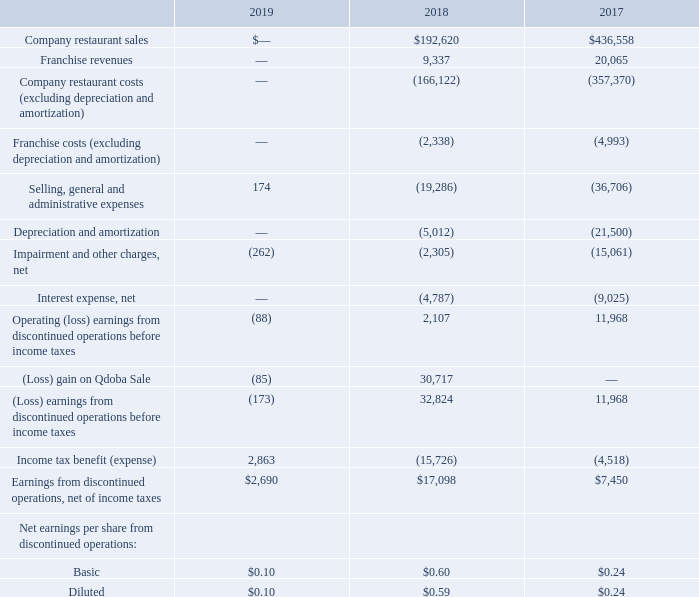The following table summarizes the Qdoba results for each period (in thousands, except per share data):
Selling, general and administrative expenses presented in the table above include corporate costs directly in support of Qdoba operations. All other corporate costs were classified in results of continuing operations. Our credit facility required us to make a mandatory prepayment (“Qdoba Prepayment”) on our term loan upon the closing of the Qdoba Sale, which was $260.0 million. Interest expense associated with our credit facility was allocated to discontinued operations based on our estimate of the mandatory prepayment that was made upon closing of the Qdoba Sale.
Lease guarantees — While all operating leases held in the name of Qdoba were part of the Qdoba Sale, some of the leases remain guaranteed by the Company pursuant to one or more written guarantees (the “Guarantees”). In the event Qdoba fails to meet its payment and performance obligations under such guaranteed leases, we may be required to make rent and other payments to the landlord under the requirements of the Guarantees. Should we, as guarantor of the lease obligations, be required to make any lease payments due for the remaining term of the subject lease(s) subsequent to March 21, 2018, the maximum amount we may be required to pay is approximately$32.1 million as ofSeptember 29, 2019. The lease terms extend for a maximum of approximately16 more years as of September 29, 2019, and we would remain a guarantor of the leases in the event the leases are extended for any established renewal periods. In the event that we are obligated to make payments under the Guarantees, we believe the exposure is limited due to contractual protections and recourse available in the lease agreements, as well as the Qdoba Purchase Agreement, including a requirement of the landlord to mitigate damages by re-letting the properties in default, and indemnity from the Buyer. Qdoba continues to meet its obligations under these leases and there have not been any events that would indicate that Qdoba will not continue to meet the obligations of the leases. As such, we have not recorded a liability for the Guarantees as of September 29, 2019 as the likelihood of Qdoba defaulting on the assigned agreements was deemed to be less than probable.
How much was the Qdoba Prepayment? $260.0 million. What is the company restaurant sales in 2018?
Answer scale should be: thousand. $192,620. Where was interest expense associated with our credit facility allocated to? Discontinued operations. What is the difference in company restaurant sales between 2017 and 2018?
Answer scale should be: thousand. $436,558-$192,620
Answer: 243938. What is the average basic net earnings per share from discontinued operations from 2017-2019? (0.10+0.60+0.24)/3
Answer: 0.31. What is the difference in franchise revenues between 2017 and 2018?
Answer scale should be: thousand. 20,065-9,337
Answer: 10728. 